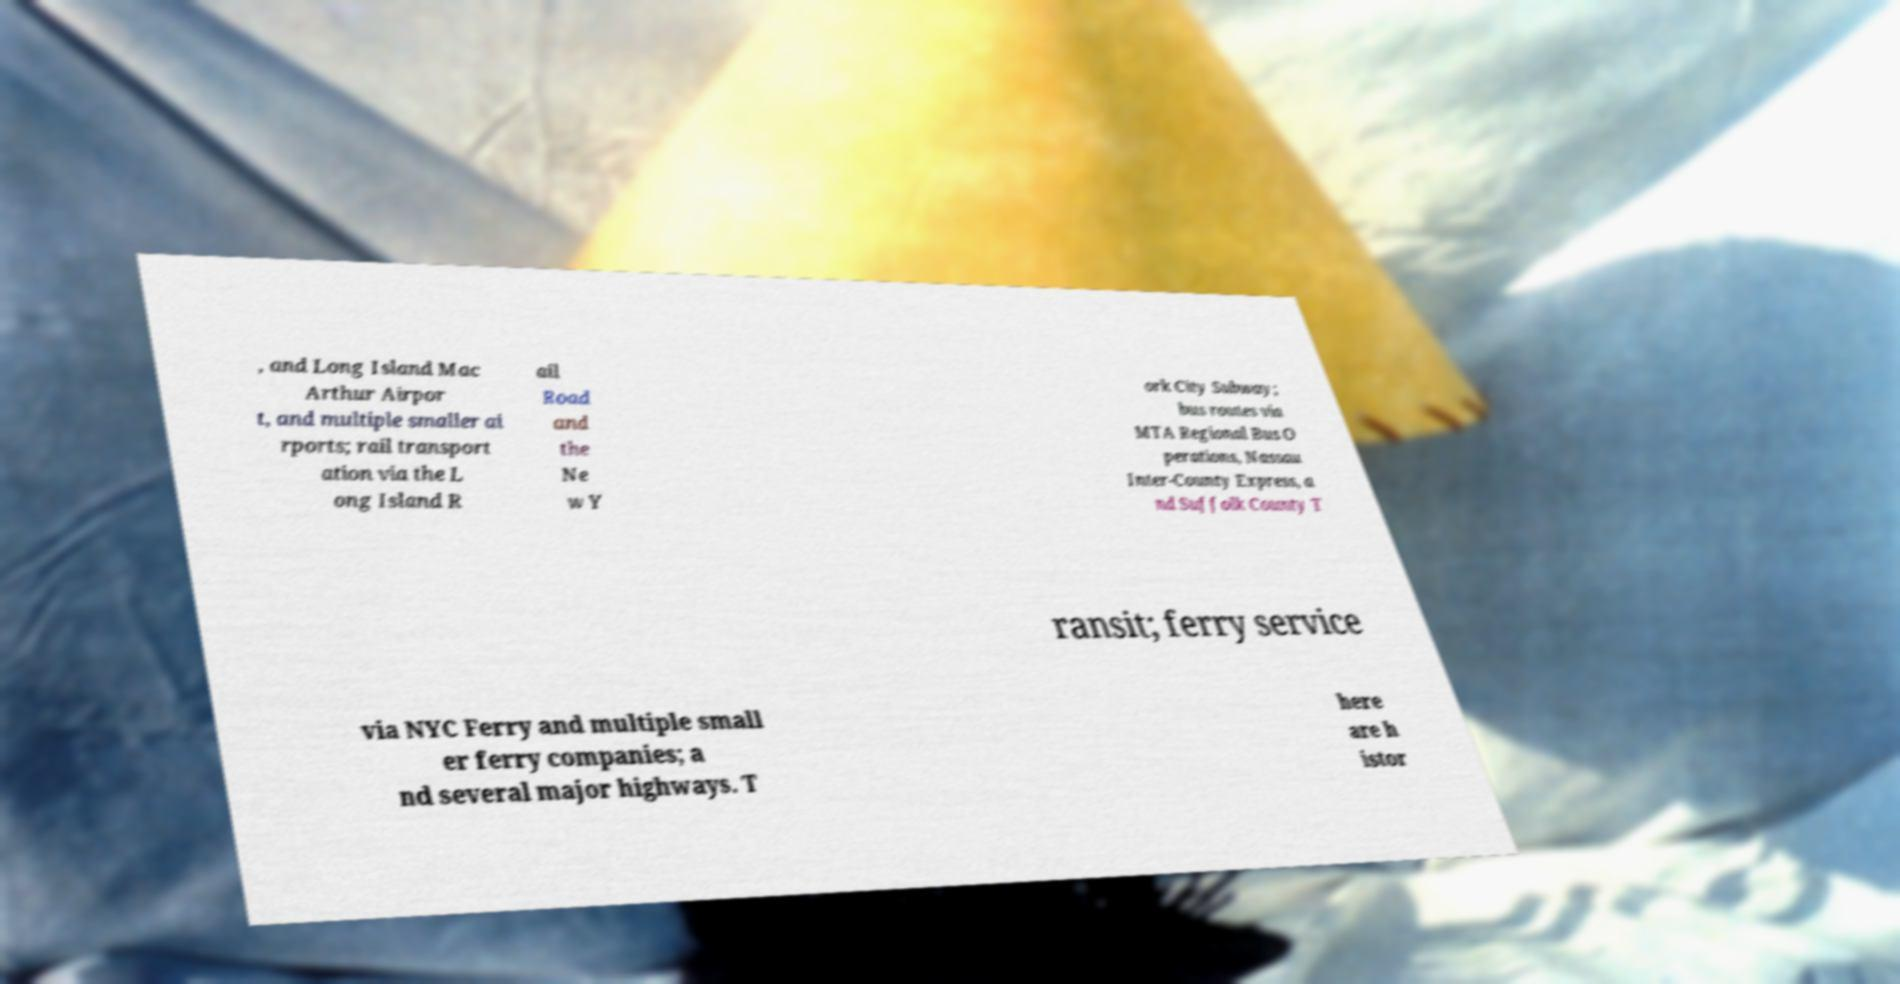There's text embedded in this image that I need extracted. Can you transcribe it verbatim? , and Long Island Mac Arthur Airpor t, and multiple smaller ai rports; rail transport ation via the L ong Island R ail Road and the Ne w Y ork City Subway; bus routes via MTA Regional Bus O perations, Nassau Inter-County Express, a nd Suffolk County T ransit; ferry service via NYC Ferry and multiple small er ferry companies; a nd several major highways. T here are h istor 